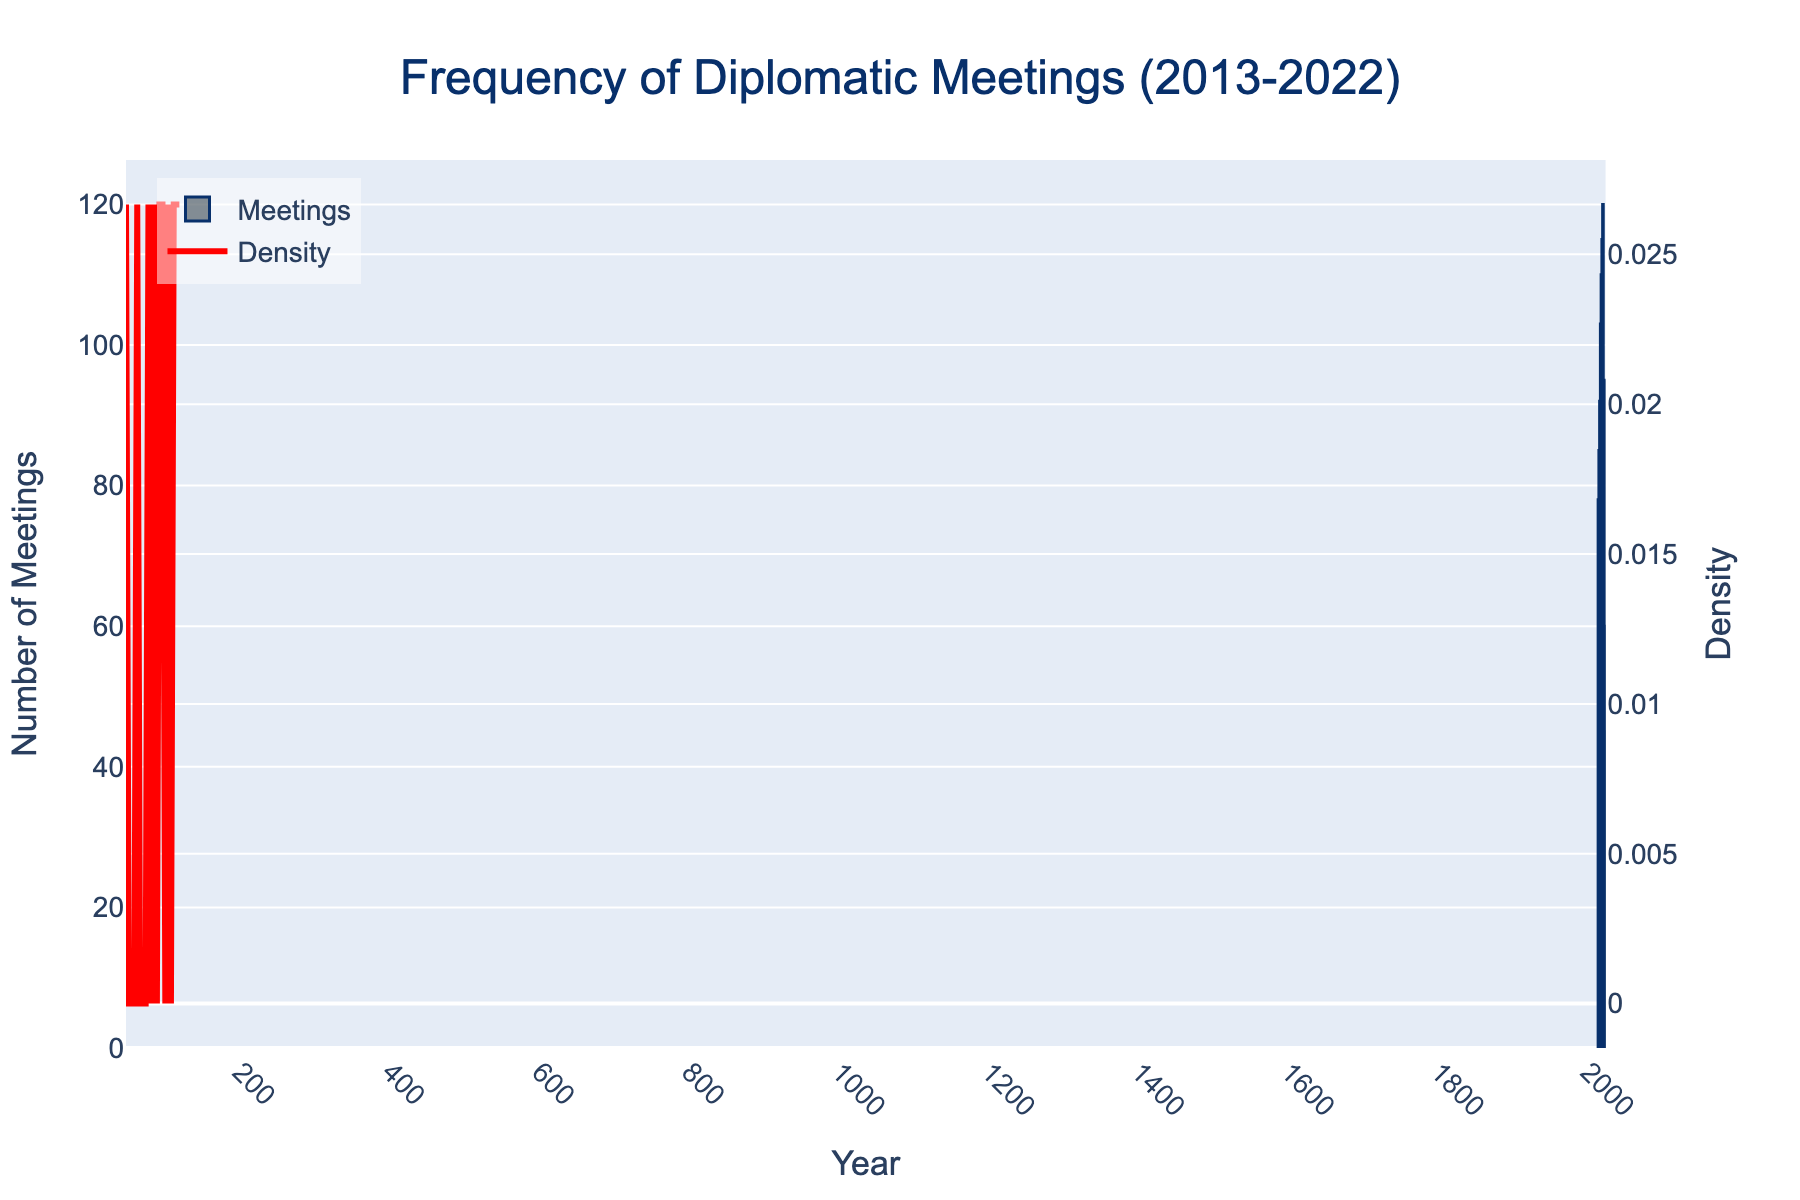What's the title of the figure? The title of the figure is located at the top and provides a brief description of what the figure represents. Here, it's clearly written at the top center in larger font.
Answer: Frequency of Diplomatic Meetings (2013-2022) What does the KDE curve represent in the plot? The KDE (Kernel Density Estimate) curve represents the probability density function of the frequency distribution of meetings. It is plotted alongside the histogram to show the underlying distribution of the data points.
Answer: The probability density of the number of meetings What is the trend in the number of diplomatic meetings from 2013 to 2019? Observing the histogram bars from 2013 to 2019 shows a clear upward trend. Each subsequent year has a higher number of meetings, illustrating an increase over these years.
Answer: Increasing Which year had the highest number of diplomatic meetings? By looking at the heights of the histogram bars, we can determine the year with the peak value. The tallest bar represents the highest number of meetings. Here, 2019 has the tallest bar.
Answer: 2019 How does the number of meetings in 2020 compare to 2019? Comparing the heights of the bars for 2019 and 2020, we see a significant drop in the number of meetings. The bar for 2020 is much shorter.
Answer: Lower What's the exact number of diplomatic meetings in 2020? The figure has labels on the y-axis indicating the number of meetings. The height of the bar for 2020 aligns with a specific value.
Answer: 45 What does the secondary y-axis represent in this figure? The secondary y-axis, shown on the right side, is used to indicate the density values for the KDE curve. It helps in understanding the density distribution separately from the count.
Answer: Density What's the overall trend in diplomatic meetings between 2021 and 2022? By comparing the histogram bars for 2021 and 2022, we can observe an upward trend. The number of meetings increased from 60 in 2021 to 95 in 2022.
Answer: Increasing Between which years did the sharpest decline in the number of meetings occur? By analyzing the histogram bars, it's evident that the most significant drop in meetings happened between 2019 and 2020 as the height dropped substantially.
Answer: 2019 and 2020 Is there a correlation between the number of meetings and the density shown by the KDE curve? The KDE curve shows high-density peaks where the number of meetings is frequent. Lower or smaller bars correspond to lower peaks in the KDE curve, indicating a correlation.
Answer: Yes 